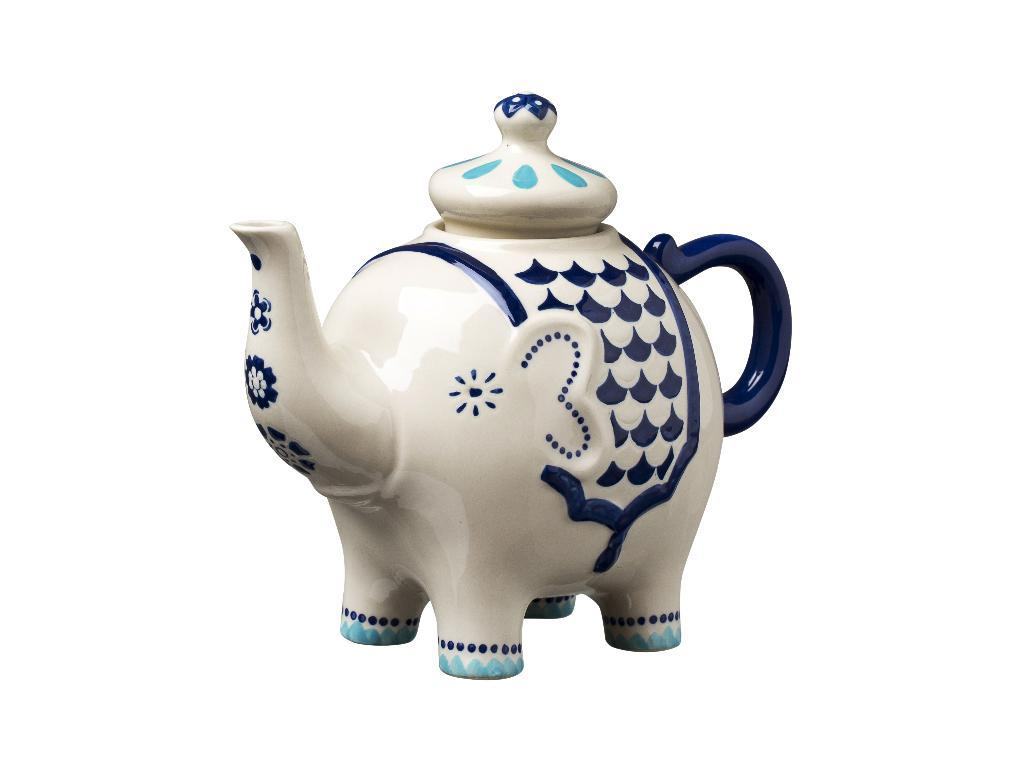What is the main object in the image? There is a teapot in the image. What type of boot is being used to stir the sugar in the teapot? There is no boot or sugar present in the image; it only features a teapot. 